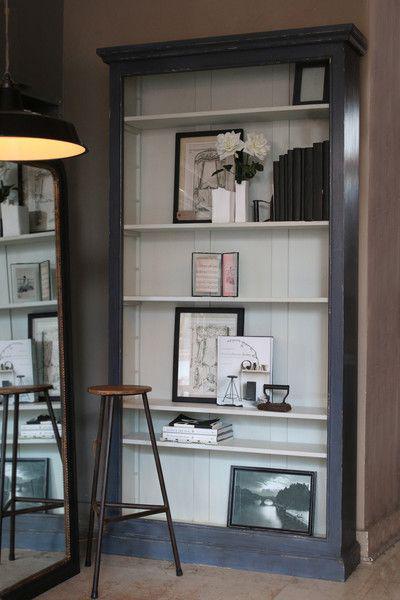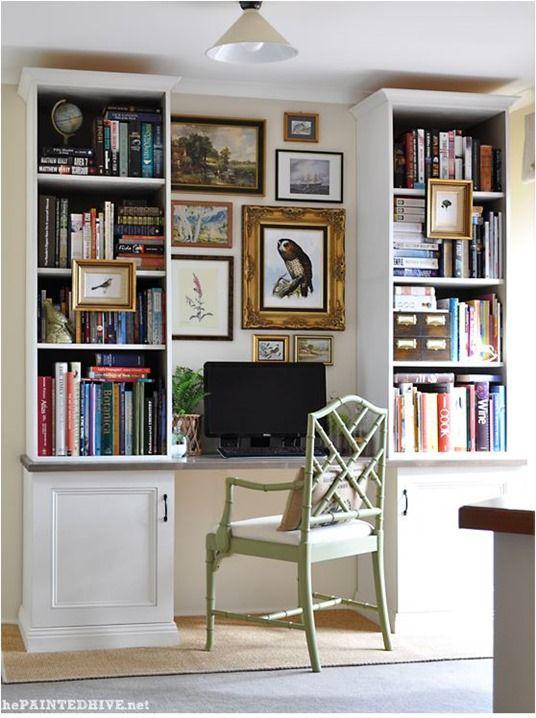The first image is the image on the left, the second image is the image on the right. For the images displayed, is the sentence "The left image shows a non-white shelf unit that leans against a wall like a ladder and has three vertical sections, with a small desk in the center with a chair pulled up to it." factually correct? Answer yes or no. No. The first image is the image on the left, the second image is the image on the right. Evaluate the accuracy of this statement regarding the images: "The left and right image contains the same number of attached bookshelves.". Is it true? Answer yes or no. No. 